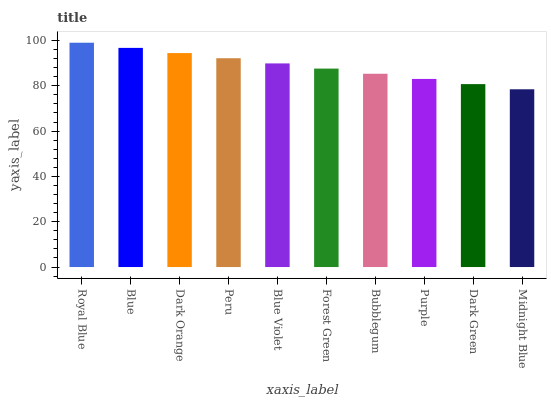Is Midnight Blue the minimum?
Answer yes or no. Yes. Is Royal Blue the maximum?
Answer yes or no. Yes. Is Blue the minimum?
Answer yes or no. No. Is Blue the maximum?
Answer yes or no. No. Is Royal Blue greater than Blue?
Answer yes or no. Yes. Is Blue less than Royal Blue?
Answer yes or no. Yes. Is Blue greater than Royal Blue?
Answer yes or no. No. Is Royal Blue less than Blue?
Answer yes or no. No. Is Blue Violet the high median?
Answer yes or no. Yes. Is Forest Green the low median?
Answer yes or no. Yes. Is Dark Green the high median?
Answer yes or no. No. Is Royal Blue the low median?
Answer yes or no. No. 